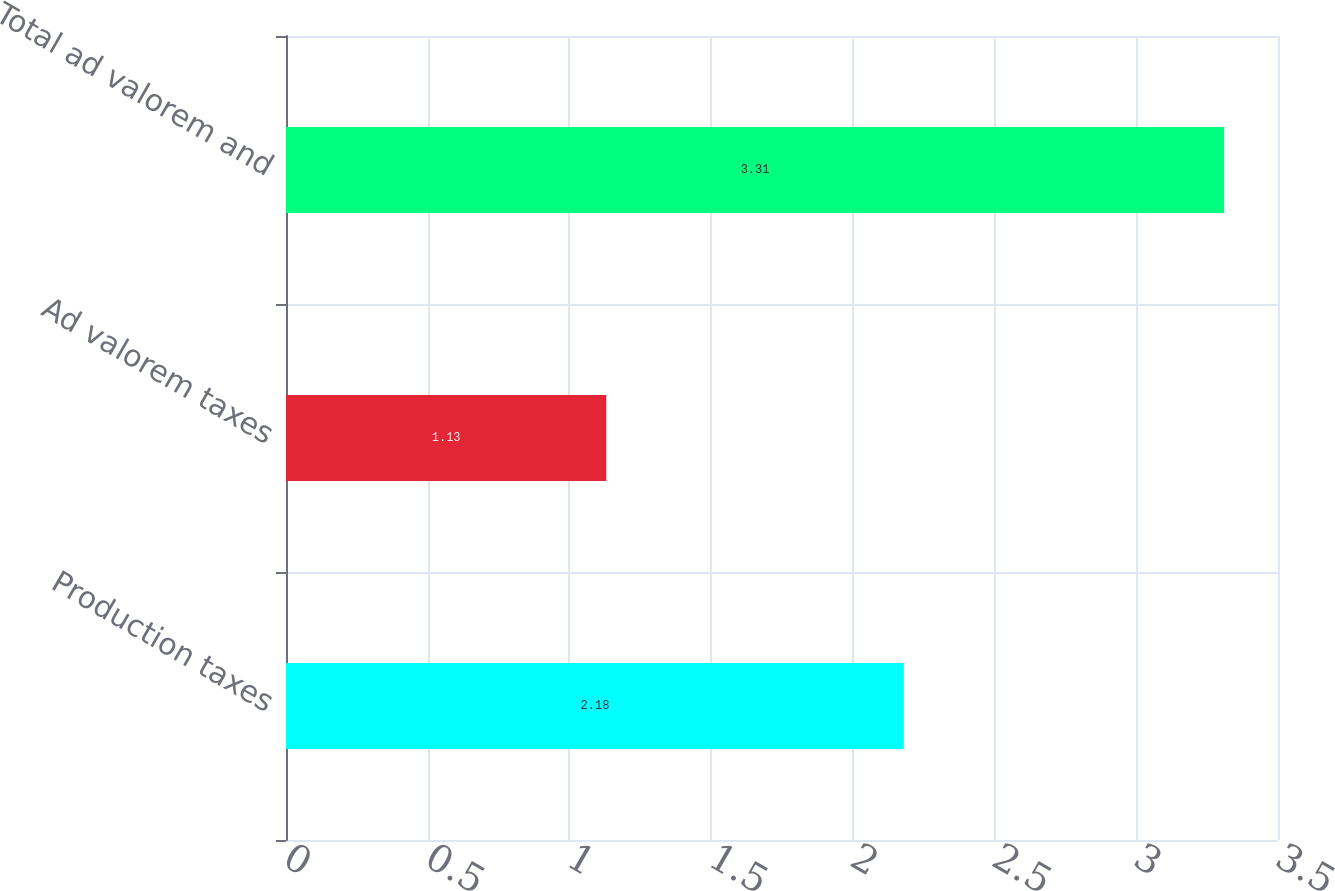<chart> <loc_0><loc_0><loc_500><loc_500><bar_chart><fcel>Production taxes<fcel>Ad valorem taxes<fcel>Total ad valorem and<nl><fcel>2.18<fcel>1.13<fcel>3.31<nl></chart> 